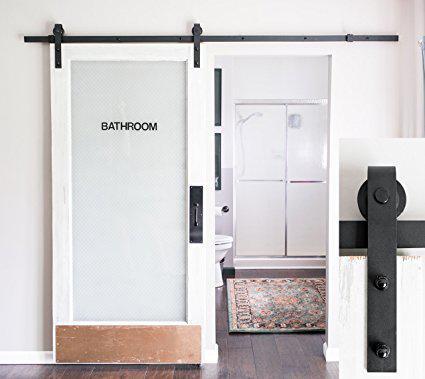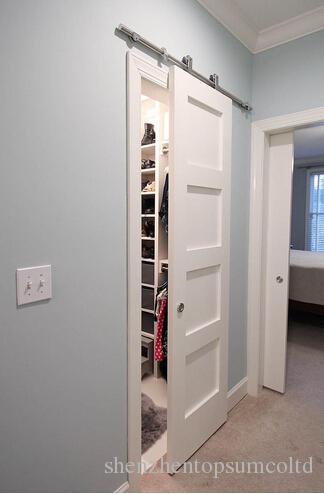The first image is the image on the left, the second image is the image on the right. Analyze the images presented: Is the assertion "There is  total of two white hanging doors." valid? Answer yes or no. Yes. The first image is the image on the left, the second image is the image on the right. Assess this claim about the two images: "A white door that slides on a black bar overhead has a brown rectangular 'kickplate' at the bottom of the open door.". Correct or not? Answer yes or no. Yes. 